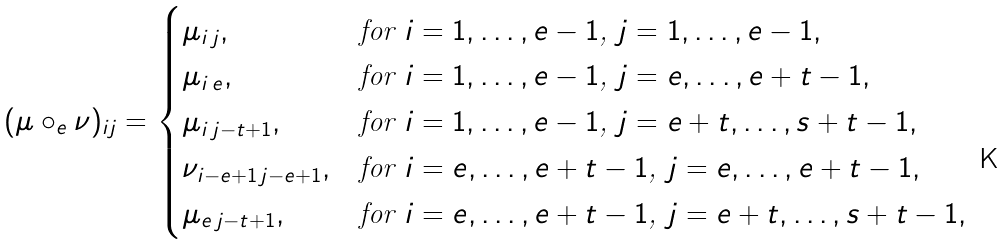<formula> <loc_0><loc_0><loc_500><loc_500>( \mu \circ _ { e } \nu ) _ { i j } = \begin{cases} \mu _ { i \, j } , & \text {for $i = 1,\dots,e-1$, $j = 1,\dots,e-1$} , \\ \mu _ { i \, e } , & \text {for $i = 1,\dots,e-1$, $j = e,\dots,e+t-1$} , \\ \mu _ { i \, j - t + 1 } , & \text {for $i = 1,\dots,e-1$, $j = e+t,\dots,s+t-1$} , \\ \nu _ { i - e + 1 \, j - e + 1 } , & \text {for $i = e,\dots,e+t-1$, $j = e,\dots,e+t-1$} , \\ \mu _ { e \, j - t + 1 } , & \text {for $i = e,\dots,e+t-1$, $j = e+t,\dots,s+t-1$} , \end{cases}</formula> 